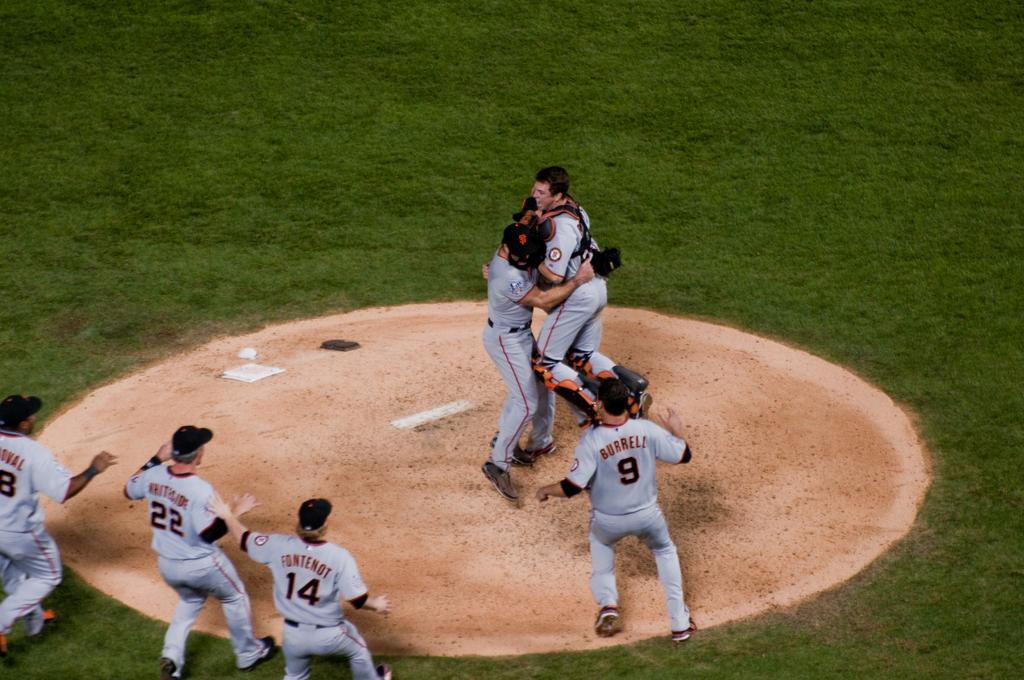<image>
Give a short and clear explanation of the subsequent image. San Francisco Giants team hugging each other and celebrating for winning a baseball game. 